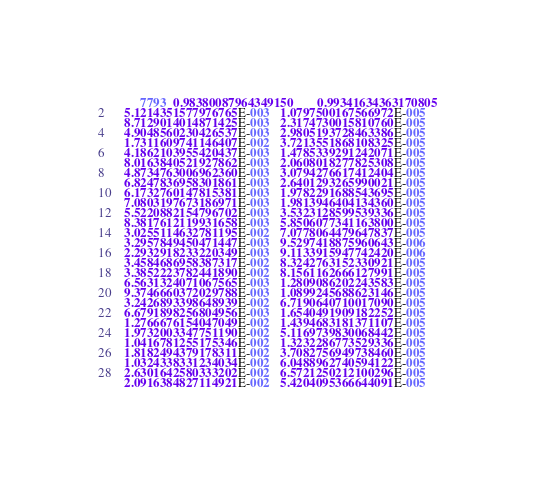Convert code to text. <code><loc_0><loc_0><loc_500><loc_500><_SML_>        7793  0.98380087964349150       0.99341634363170805     
   5.1214351577976765E-003   1.0797500167566972E-005
   8.7129014014871425E-003   2.3174730015810760E-005
   4.9048560230426537E-003   2.9805193728463386E-005
   1.7311609741146407E-002   3.7213551868108325E-005
   4.1862103955420437E-003   1.4785339291242071E-005
   8.0163840521927862E-003   2.0608018277825308E-005
   4.8734763006962360E-003   3.0794276617412404E-005
   6.8247836958301861E-003   2.6401293265990021E-005
   6.1732760147815381E-003   1.9782291688543695E-005
   7.0803197673186971E-003   1.9813946404134360E-005
   5.5220882154796702E-003   3.5323128599539336E-005
   8.3817612119931658E-003   5.8506077341163800E-005
   3.0255114632781195E-002   7.0778064479647837E-005
   3.2957849450471447E-003   9.5297418875960643E-006
   2.2932918233220349E-003   9.1133915947742420E-006
   3.4584686958387317E-002   8.3242763152330921E-005
   3.3852223782441890E-002   8.1561162666127991E-005
   6.5631324071067565E-003   1.2809086202243583E-005
   9.3746660372029788E-003   1.0899245688623146E-005
   3.2426893398648939E-002   6.7190640710017090E-005
   6.6791898256804956E-003   1.6540491909182252E-005
   1.2766676154047049E-002   1.4394683181371107E-005
   1.9732003347751190E-002   5.1169739830068442E-005
   1.0416781255175346E-002   1.3232286773529336E-005
   1.8182494379178311E-002   3.7082756949738460E-005
   1.0324338331234034E-002   6.0488962740594122E-005
   2.6301642580333202E-002   6.5721250212100296E-005
   2.0916384827114921E-002   5.4204095366644091E-005</code> 